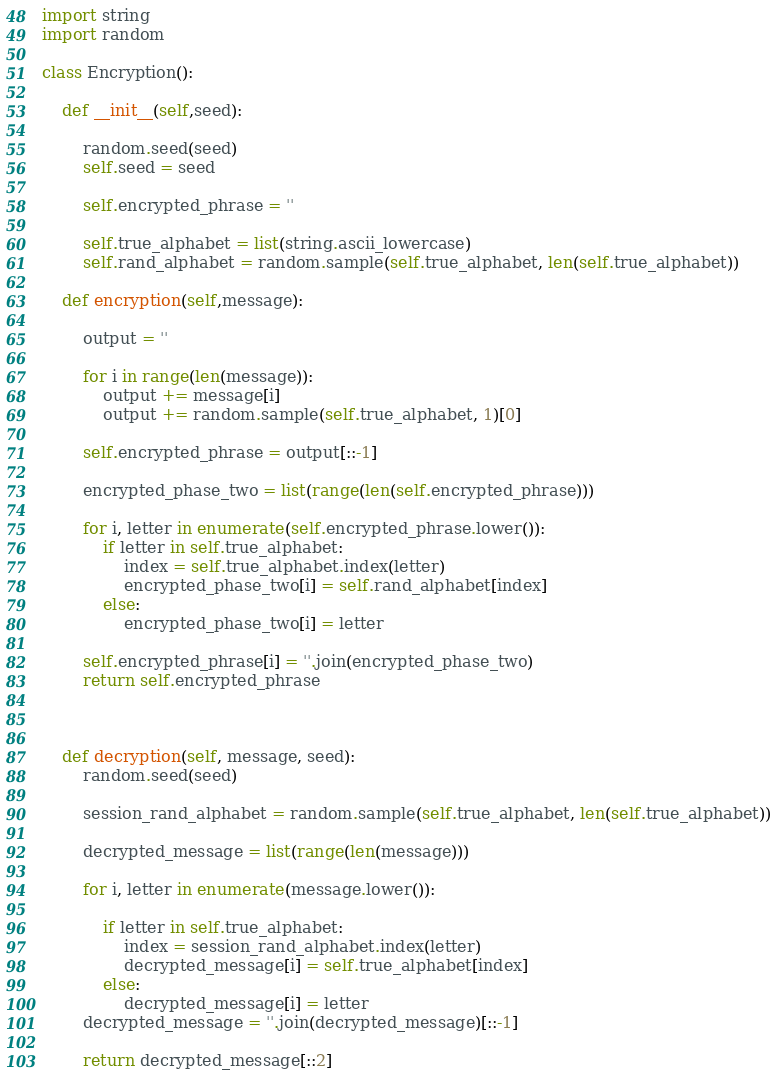<code> <loc_0><loc_0><loc_500><loc_500><_Python_>import string
import random

class Encryption():

    def __init__(self,seed):

        random.seed(seed)
        self.seed = seed

        self.encrypted_phrase = ''

        self.true_alphabet = list(string.ascii_lowercase)
        self.rand_alphabet = random.sample(self.true_alphabet, len(self.true_alphabet))

    def encryption(self,message):

        output = ''

        for i in range(len(message)):
            output += message[i]
            output += random.sample(self.true_alphabet, 1)[0]

        self.encrypted_phrase = output[::-1]

        encrypted_phase_two = list(range(len(self.encrypted_phrase)))

        for i, letter in enumerate(self.encrypted_phrase.lower()):
            if letter in self.true_alphabet:
                index = self.true_alphabet.index(letter)
                encrypted_phase_two[i] = self.rand_alphabet[index]
            else:
                encrypted_phase_two[i] = letter

        self.encrypted_phrase[i] = ''.join(encrypted_phase_two)
        return self.encrypted_phrase



    def decryption(self, message, seed):
        random.seed(seed)

        session_rand_alphabet = random.sample(self.true_alphabet, len(self.true_alphabet))

        decrypted_message = list(range(len(message)))

        for i, letter in enumerate(message.lower()):

            if letter in self.true_alphabet:
                index = session_rand_alphabet.index(letter)
                decrypted_message[i] = self.true_alphabet[index]
            else:
                decrypted_message[i] = letter
        decrypted_message = ''.join(decrypted_message)[::-1]

        return decrypted_message[::2]


</code> 